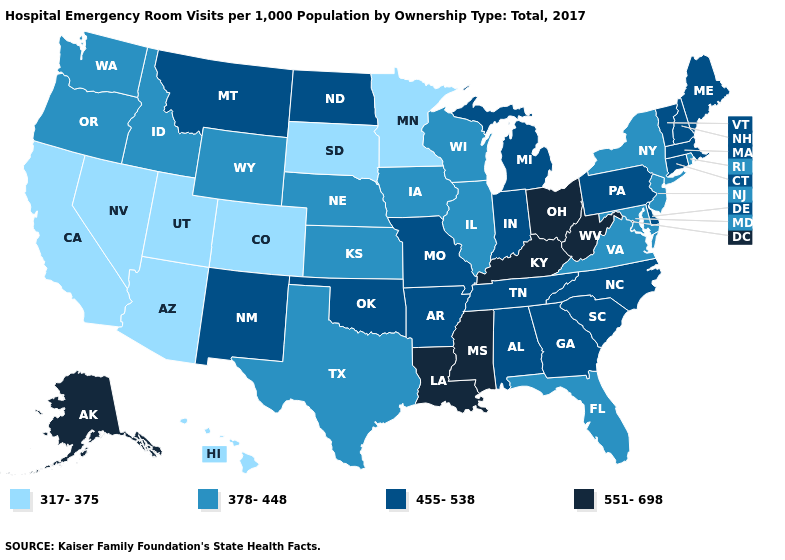What is the value of West Virginia?
Keep it brief. 551-698. Name the states that have a value in the range 551-698?
Keep it brief. Alaska, Kentucky, Louisiana, Mississippi, Ohio, West Virginia. Does the first symbol in the legend represent the smallest category?
Be succinct. Yes. Name the states that have a value in the range 317-375?
Short answer required. Arizona, California, Colorado, Hawaii, Minnesota, Nevada, South Dakota, Utah. Does North Dakota have the highest value in the MidWest?
Be succinct. No. Among the states that border Texas , does Louisiana have the highest value?
Answer briefly. Yes. Among the states that border New Mexico , which have the lowest value?
Answer briefly. Arizona, Colorado, Utah. Name the states that have a value in the range 317-375?
Answer briefly. Arizona, California, Colorado, Hawaii, Minnesota, Nevada, South Dakota, Utah. What is the lowest value in states that border South Dakota?
Answer briefly. 317-375. Which states have the lowest value in the USA?
Short answer required. Arizona, California, Colorado, Hawaii, Minnesota, Nevada, South Dakota, Utah. What is the value of Massachusetts?
Keep it brief. 455-538. Which states have the lowest value in the USA?
Short answer required. Arizona, California, Colorado, Hawaii, Minnesota, Nevada, South Dakota, Utah. Which states hav the highest value in the West?
Be succinct. Alaska. Among the states that border Pennsylvania , which have the lowest value?
Give a very brief answer. Maryland, New Jersey, New York. 